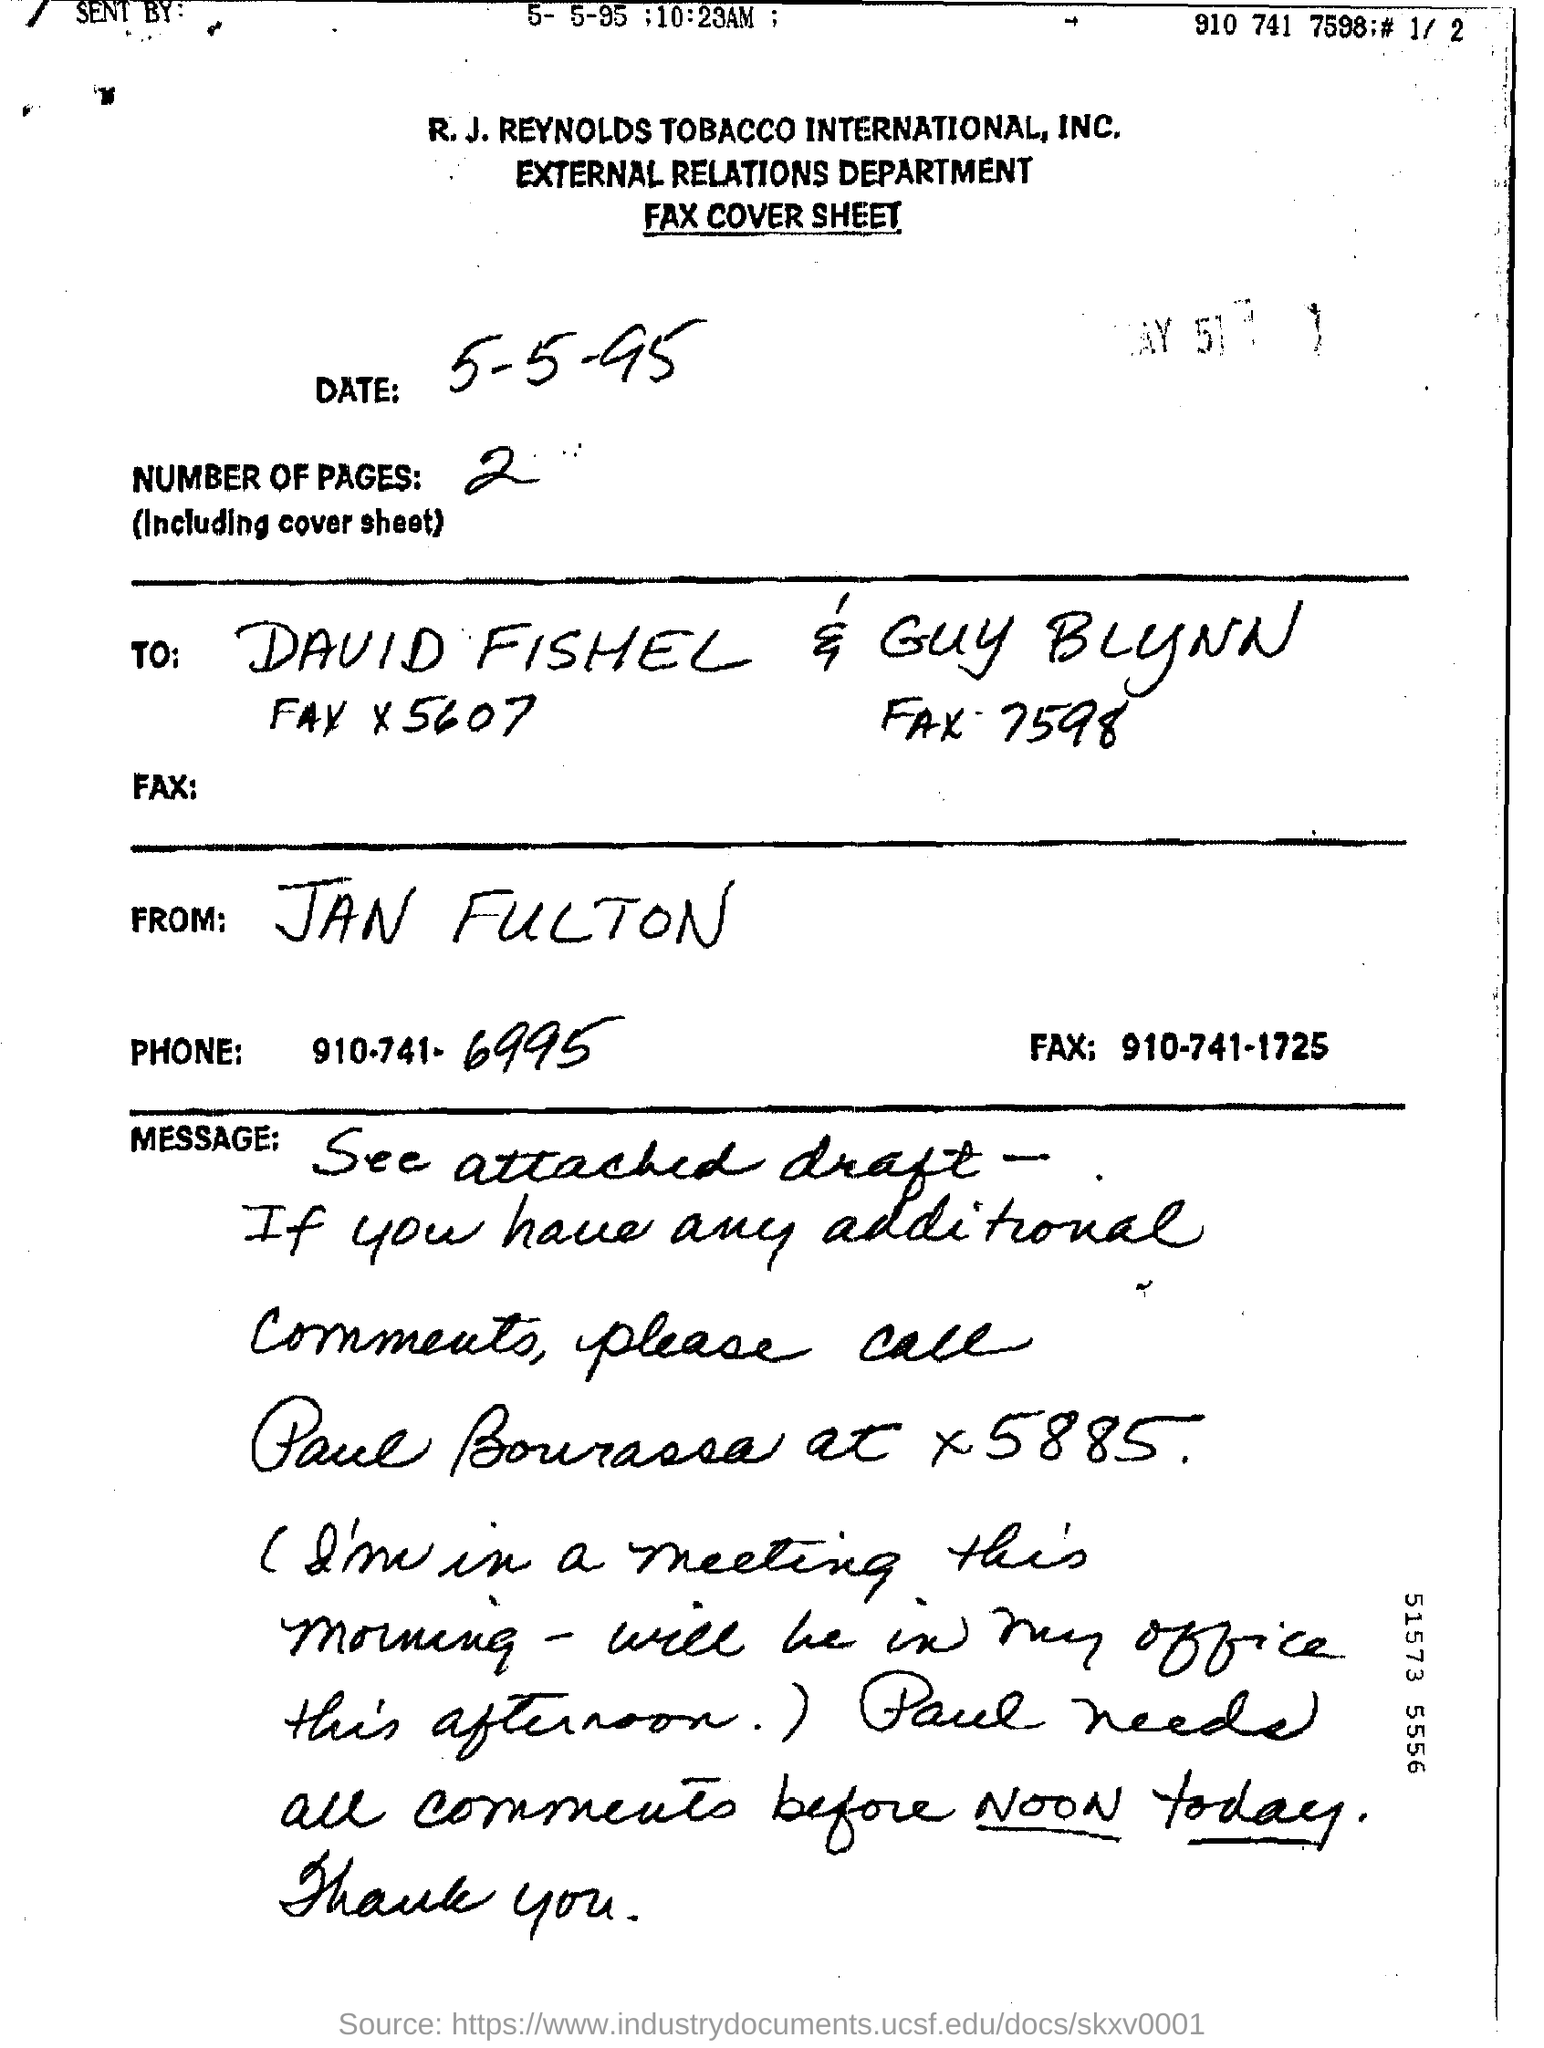What sheet is it?
Your response must be concise. Fax cover sheet. What department does the title read?
Your answer should be very brief. EXTERNAL RELATIONS. Who sent the sheet?
Your answer should be compact. Jan fulton. What are the last four digits of the phone number?
Your answer should be very brief. 6995. 